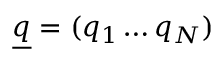<formula> <loc_0><loc_0><loc_500><loc_500>\underline { q } = ( q _ { 1 } \dots q _ { N } )</formula> 